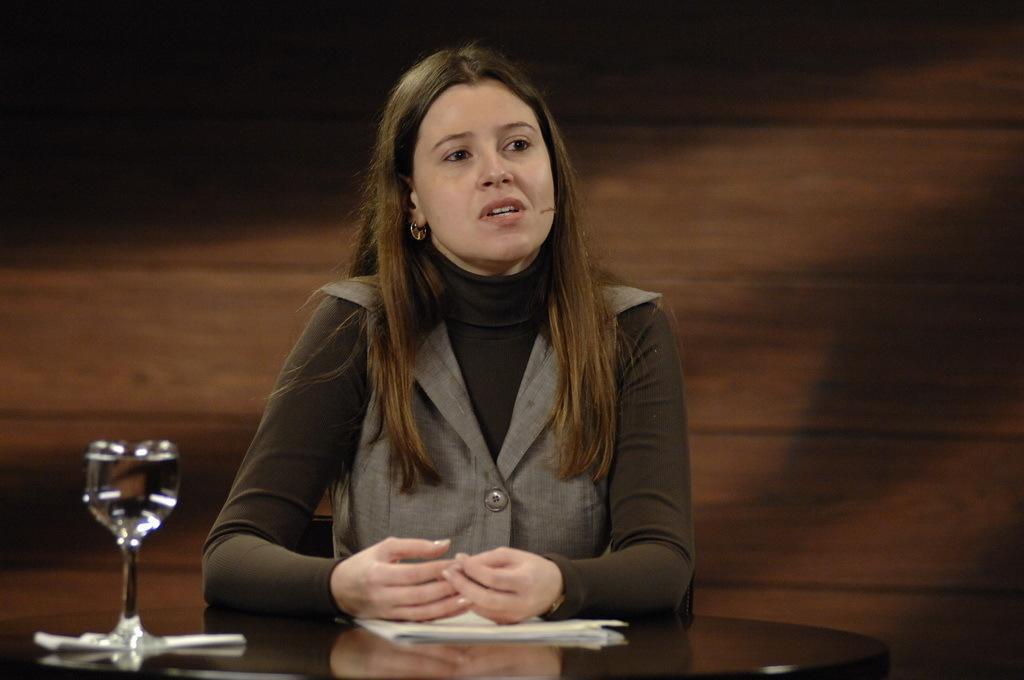In one or two sentences, can you explain what this image depicts? Front of the image we can see a table. Above this table there is a glass of water and papers. Beside this table a woman is sitting on a chair. Backside of this woman there is a wooden wall. 